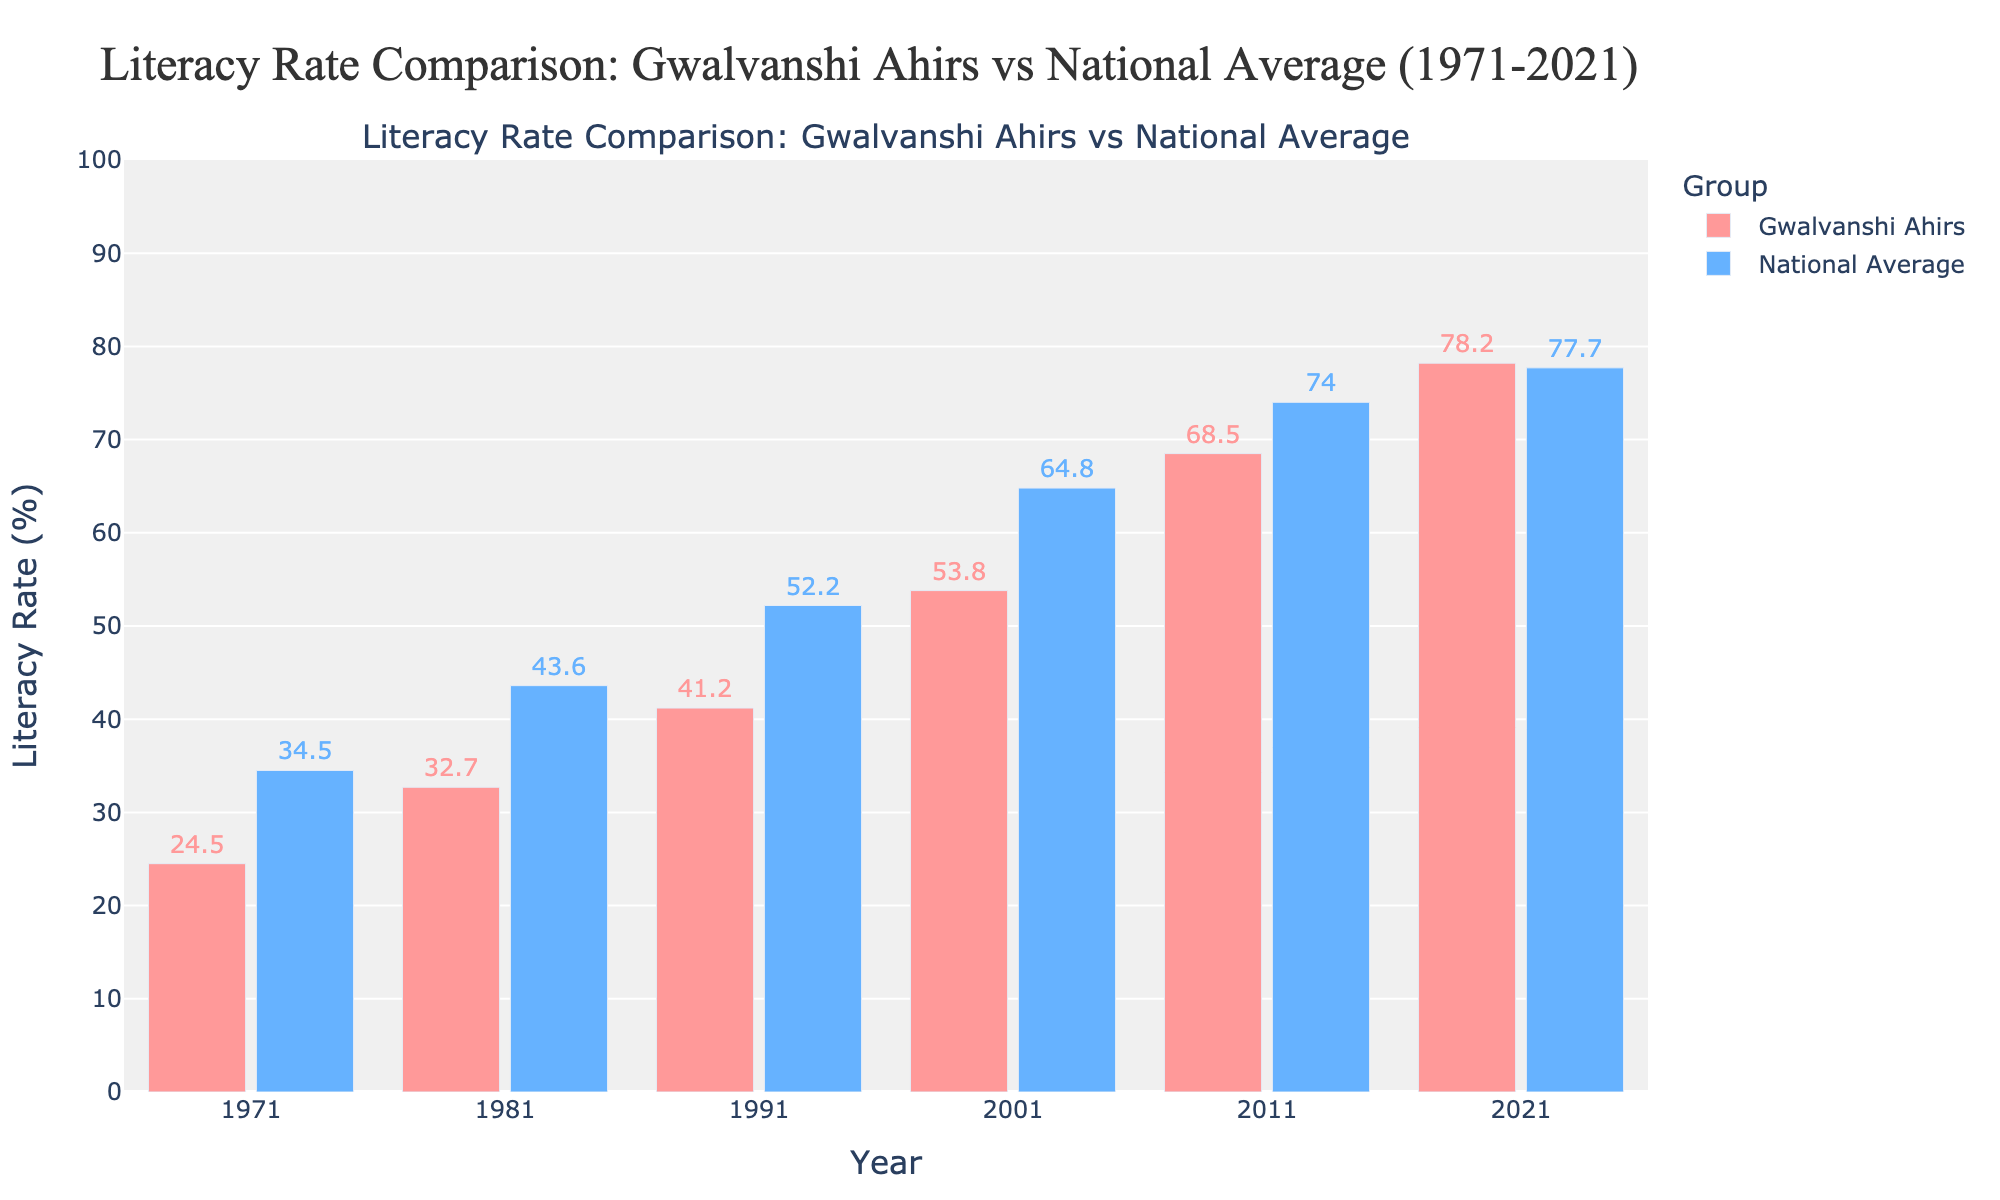What is the average literacy rate of Gwalvanshi Ahirs in 1971 and 2021? To find the average, add the literacy rates for Gwalvanshi Ahirs in 1971 and 2021, then divide by 2: (24.5 + 78.2) / 2.
Answer: 51.35 In which year did the Gwalvanshi Ahirs' literacy rate surpass the national average? Compare the literacy rates of both groups year by year. The Gwalvanshi Ahirs' literacy rate first exceeds the national average in 2021.
Answer: 2021 What is the difference in literacy rate between Gwalvanshi Ahirs and the national average in 1981? Subtract the national average literacy rate from the Gwalvanshi Ahirs' literacy rate for 1981: 32.7 - 43.6 = -10.9.
Answer: -10.9 How much did the literacy rate of Gwalvanshi Ahirs increase from 1971 to 2021? Subtract the literacy rate of 1971 from that of 2021: 78.2 - 24.5 = 53.7.
Answer: 53.7 What was the literacy rate of the national average in 2001? Refer to the bar labeled 2001 for the national average literacy rate, which is 64.8.
Answer: 64.8 By how much did the literacy rate of Gwalvanshi Ahirs increase between each decade (1971-1981, 1981-1991, etc.)? Calculate the difference for each decade: (32.7 - 24.5), (41.2 - 32.7), (53.8 - 41.2), (68.5 - 53.8), (78.2 - 68.5), resulting in increases of 8.2, 8.5, 12.6, 14.7, and 9.7, respectively.
Answer: [8.2, 8.5, 12.6, 14.7, 9.7] Which group had a higher literacy rate in 1991, and by how much? Compare the literacy rates for both groups in 1991: Gwalvanshi Ahirs at 41.2 and national average at 52.2. The national average is higher by 52.2 - 41.2 = 11.
Answer: National average by 11 What color represents the bars for Gwalvanshi Ahirs on the chart? The bars representing Gwalvanshi Ahirs are colored in a shade of red.
Answer: Red How did the literacy rate of Gwalvanshi Ahirs change relative to the national average over the 50 years period? Observe the trend: initially, the rate for Gwalvanshi Ahirs was significantly below the national average. Over time, it grew closer until it surpassed the national average in 2021.
Answer: They started below and ended above the national average What is the highest literacy rate recorded for both groups in the chart? For Gwalvanshi Ahirs, the highest literacy rate is in 2021 (78.2%). For the national average, it is in 2011 (74.0%).
Answer: 78.2% for Gwalvanshi Ahirs, 74.0% for national average 